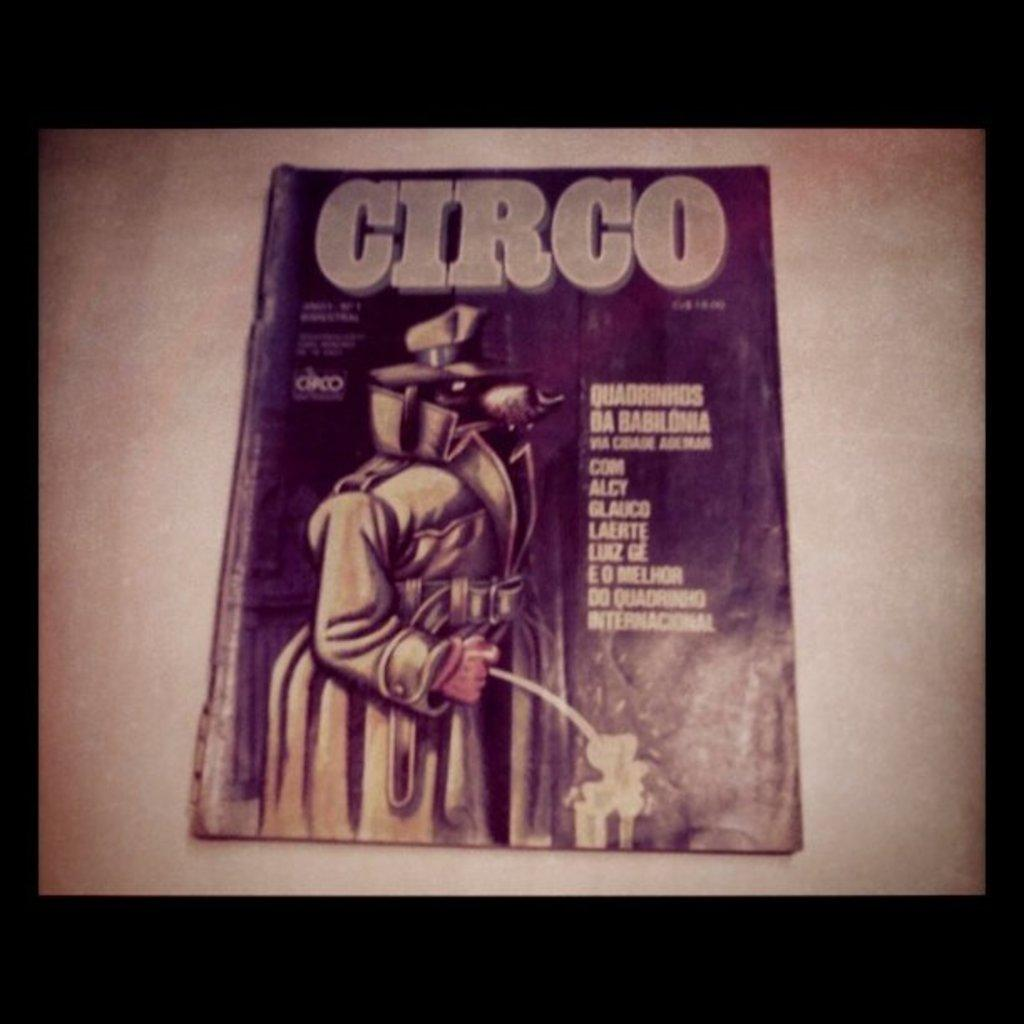<image>
Give a short and clear explanation of the subsequent image. A Circo book called Quadrinhds Da Babhonla Com Alcy 